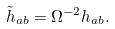Convert formula to latex. <formula><loc_0><loc_0><loc_500><loc_500>\tilde { h } _ { a b } = \Omega ^ { - 2 } h _ { a b } .</formula> 